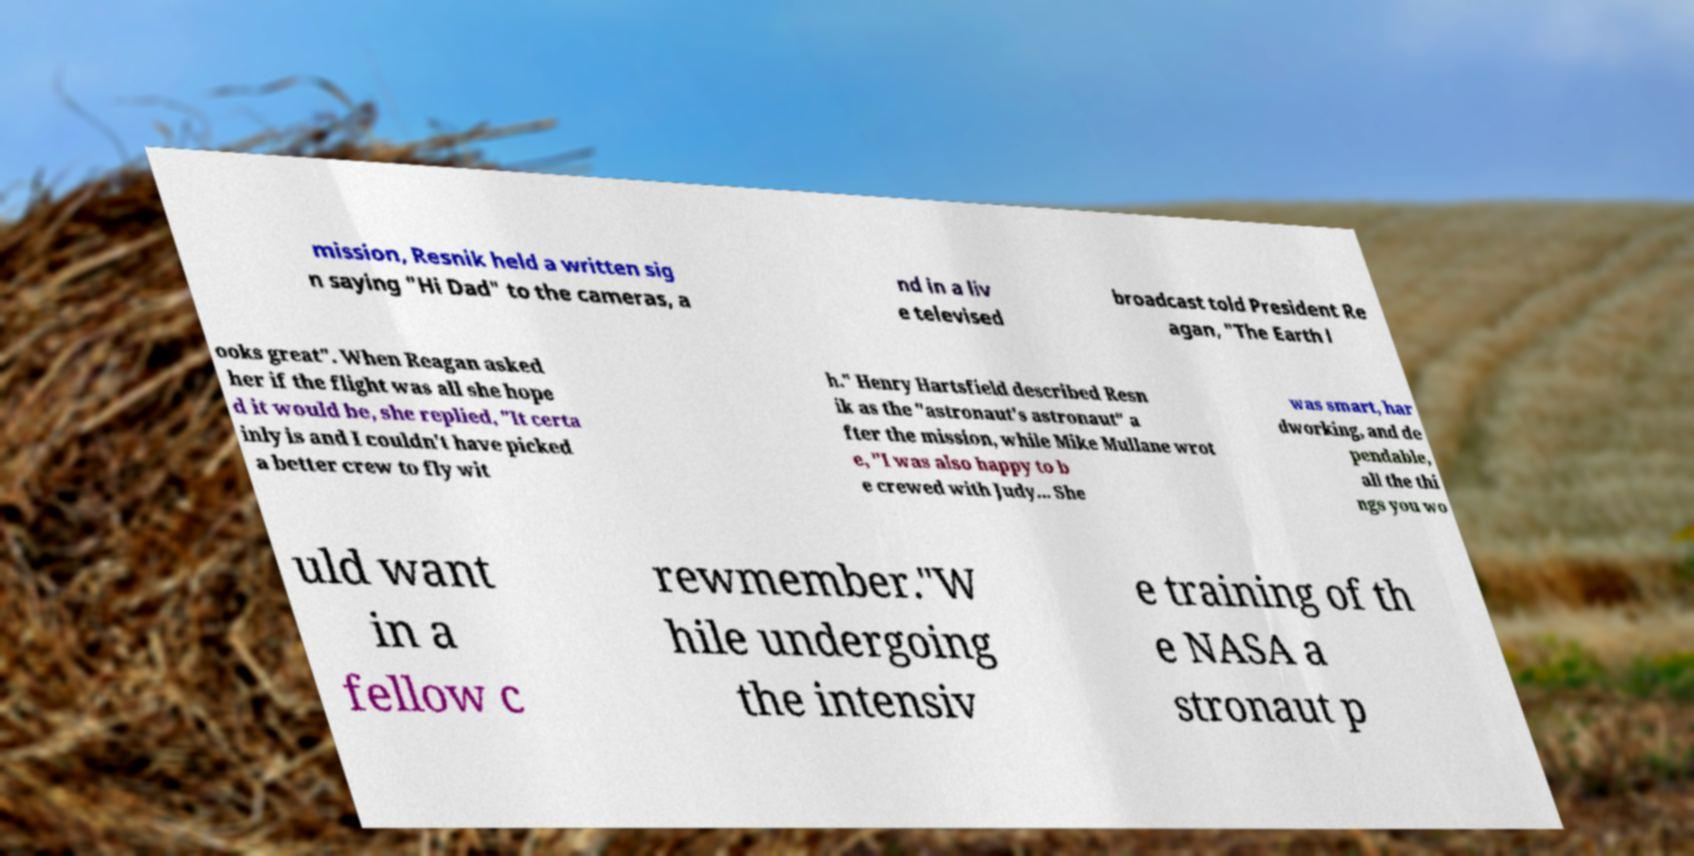There's text embedded in this image that I need extracted. Can you transcribe it verbatim? mission, Resnik held a written sig n saying "Hi Dad" to the cameras, a nd in a liv e televised broadcast told President Re agan, "The Earth l ooks great". When Reagan asked her if the flight was all she hope d it would be, she replied, "It certa inly is and I couldn't have picked a better crew to fly wit h." Henry Hartsfield described Resn ik as the "astronaut's astronaut" a fter the mission, while Mike Mullane wrot e, "I was also happy to b e crewed with Judy... She was smart, har dworking, and de pendable, all the thi ngs you wo uld want in a fellow c rewmember."W hile undergoing the intensiv e training of th e NASA a stronaut p 